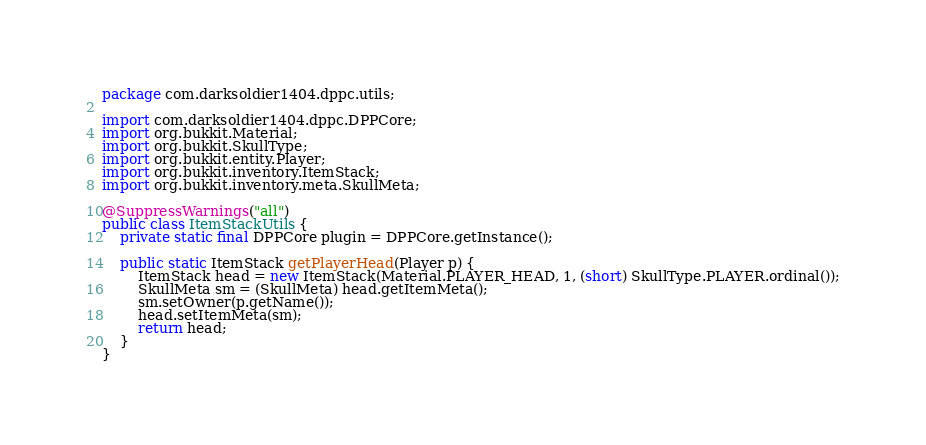<code> <loc_0><loc_0><loc_500><loc_500><_Java_>
package com.darksoldier1404.dppc.utils;

import com.darksoldier1404.dppc.DPPCore;
import org.bukkit.Material;
import org.bukkit.SkullType;
import org.bukkit.entity.Player;
import org.bukkit.inventory.ItemStack;
import org.bukkit.inventory.meta.SkullMeta;

@SuppressWarnings("all")
public class ItemStackUtils {
    private static final DPPCore plugin = DPPCore.getInstance();

    public static ItemStack getPlayerHead(Player p) {
        ItemStack head = new ItemStack(Material.PLAYER_HEAD, 1, (short) SkullType.PLAYER.ordinal());
        SkullMeta sm = (SkullMeta) head.getItemMeta();
        sm.setOwner(p.getName());
        head.setItemMeta(sm);
        return head;
    }
}
</code> 